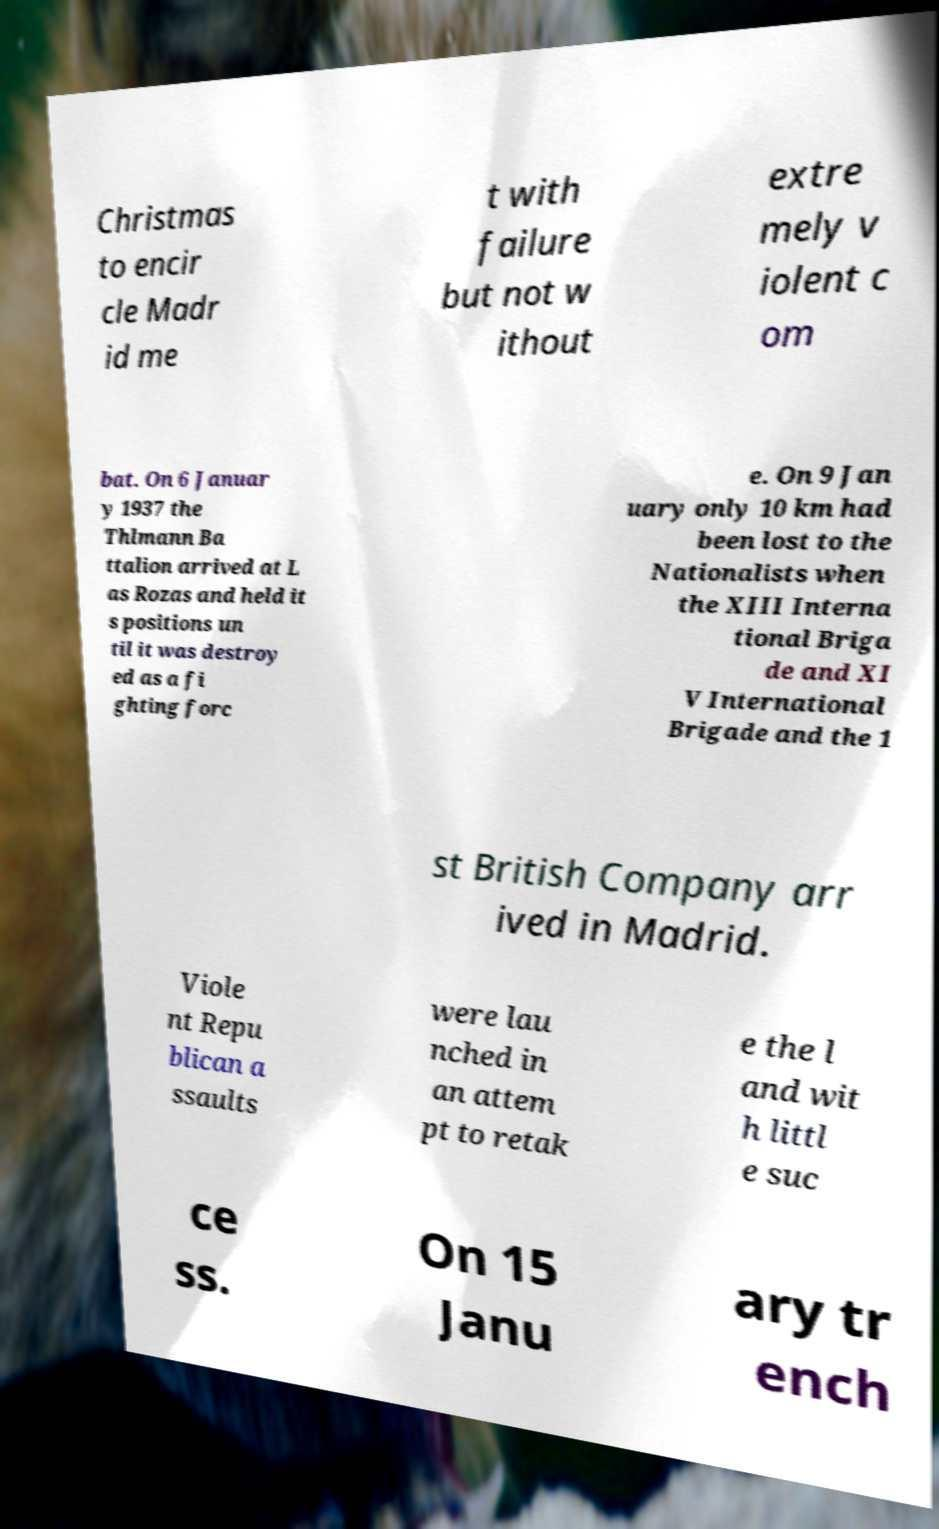There's text embedded in this image that I need extracted. Can you transcribe it verbatim? Christmas to encir cle Madr id me t with failure but not w ithout extre mely v iolent c om bat. On 6 Januar y 1937 the Thlmann Ba ttalion arrived at L as Rozas and held it s positions un til it was destroy ed as a fi ghting forc e. On 9 Jan uary only 10 km had been lost to the Nationalists when the XIII Interna tional Briga de and XI V International Brigade and the 1 st British Company arr ived in Madrid. Viole nt Repu blican a ssaults were lau nched in an attem pt to retak e the l and wit h littl e suc ce ss. On 15 Janu ary tr ench 